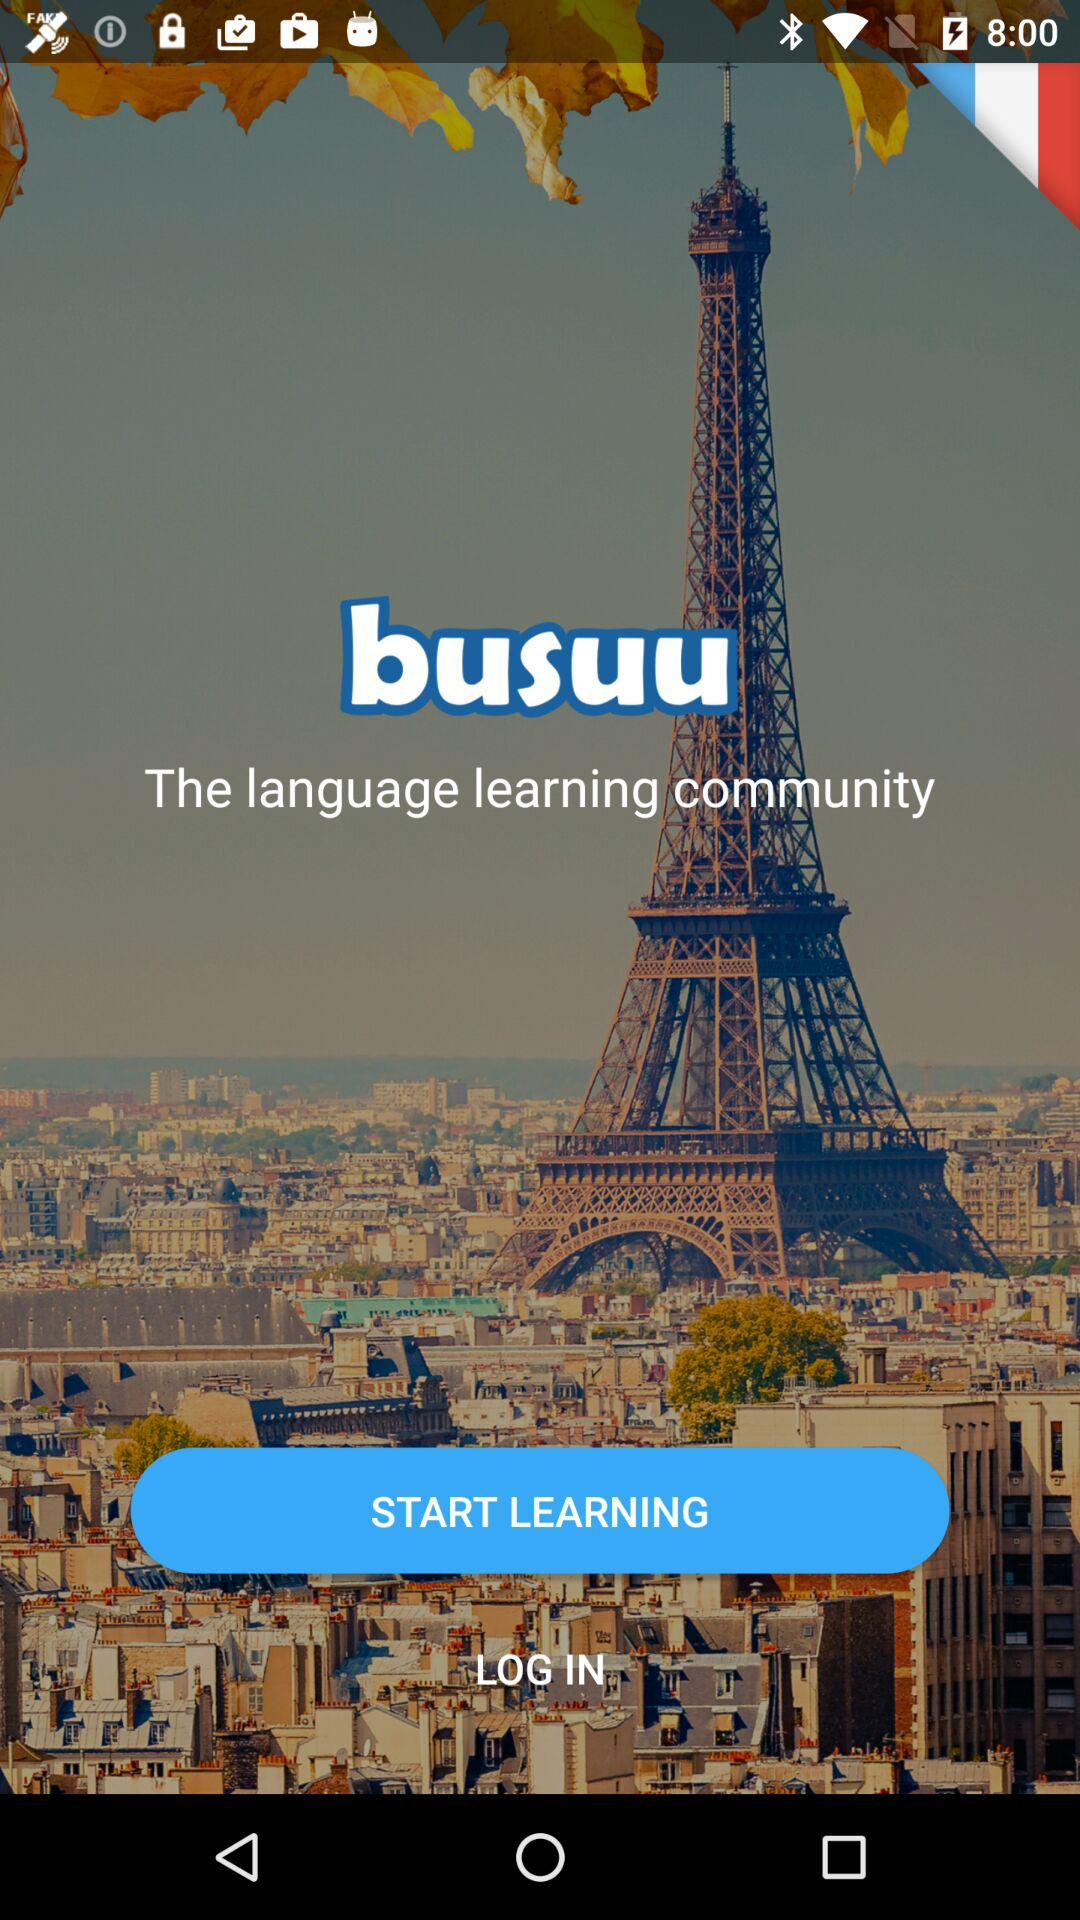What is the name of the application? The name of the application is "busuu". 